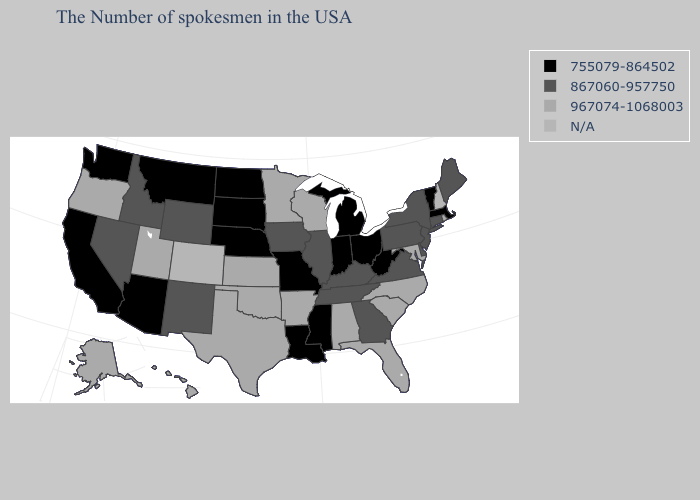What is the value of New Jersey?
Quick response, please. 867060-957750. Among the states that border Colorado , which have the highest value?
Answer briefly. Kansas, Oklahoma, Utah. What is the value of Minnesota?
Give a very brief answer. 967074-1068003. What is the value of Arkansas?
Quick response, please. 967074-1068003. Does California have the lowest value in the West?
Quick response, please. Yes. What is the lowest value in states that border Illinois?
Give a very brief answer. 755079-864502. Name the states that have a value in the range 967074-1068003?
Quick response, please. Rhode Island, Maryland, North Carolina, South Carolina, Florida, Alabama, Wisconsin, Arkansas, Minnesota, Kansas, Oklahoma, Texas, Utah, Oregon, Alaska, Hawaii. Which states hav the highest value in the Northeast?
Give a very brief answer. Rhode Island. Is the legend a continuous bar?
Give a very brief answer. No. What is the value of Missouri?
Answer briefly. 755079-864502. What is the value of Missouri?
Answer briefly. 755079-864502. What is the highest value in the Northeast ?
Quick response, please. 967074-1068003. Which states have the highest value in the USA?
Be succinct. Rhode Island, Maryland, North Carolina, South Carolina, Florida, Alabama, Wisconsin, Arkansas, Minnesota, Kansas, Oklahoma, Texas, Utah, Oregon, Alaska, Hawaii. What is the value of Oregon?
Concise answer only. 967074-1068003. 